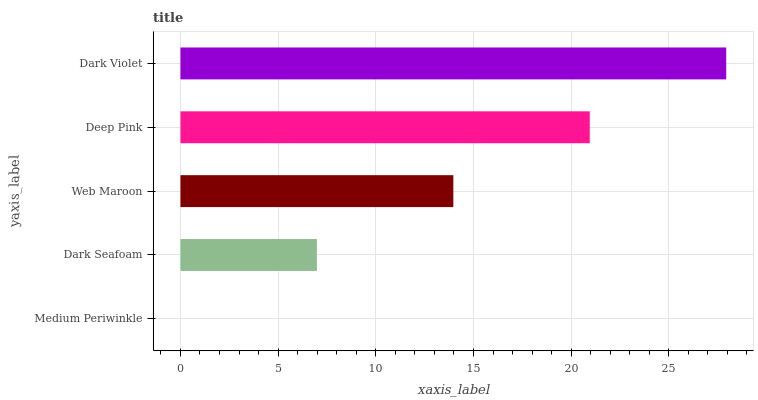Is Medium Periwinkle the minimum?
Answer yes or no. Yes. Is Dark Violet the maximum?
Answer yes or no. Yes. Is Dark Seafoam the minimum?
Answer yes or no. No. Is Dark Seafoam the maximum?
Answer yes or no. No. Is Dark Seafoam greater than Medium Periwinkle?
Answer yes or no. Yes. Is Medium Periwinkle less than Dark Seafoam?
Answer yes or no. Yes. Is Medium Periwinkle greater than Dark Seafoam?
Answer yes or no. No. Is Dark Seafoam less than Medium Periwinkle?
Answer yes or no. No. Is Web Maroon the high median?
Answer yes or no. Yes. Is Web Maroon the low median?
Answer yes or no. Yes. Is Medium Periwinkle the high median?
Answer yes or no. No. Is Deep Pink the low median?
Answer yes or no. No. 